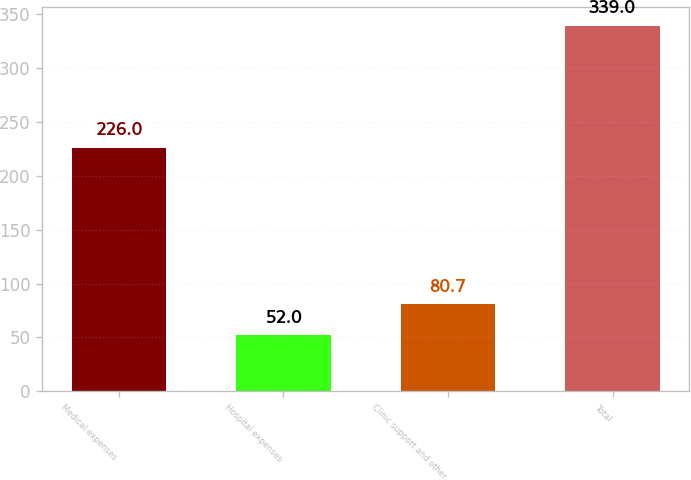Convert chart to OTSL. <chart><loc_0><loc_0><loc_500><loc_500><bar_chart><fcel>Medical expenses<fcel>Hospital expenses<fcel>Clinic support and other<fcel>Total<nl><fcel>226<fcel>52<fcel>80.7<fcel>339<nl></chart> 